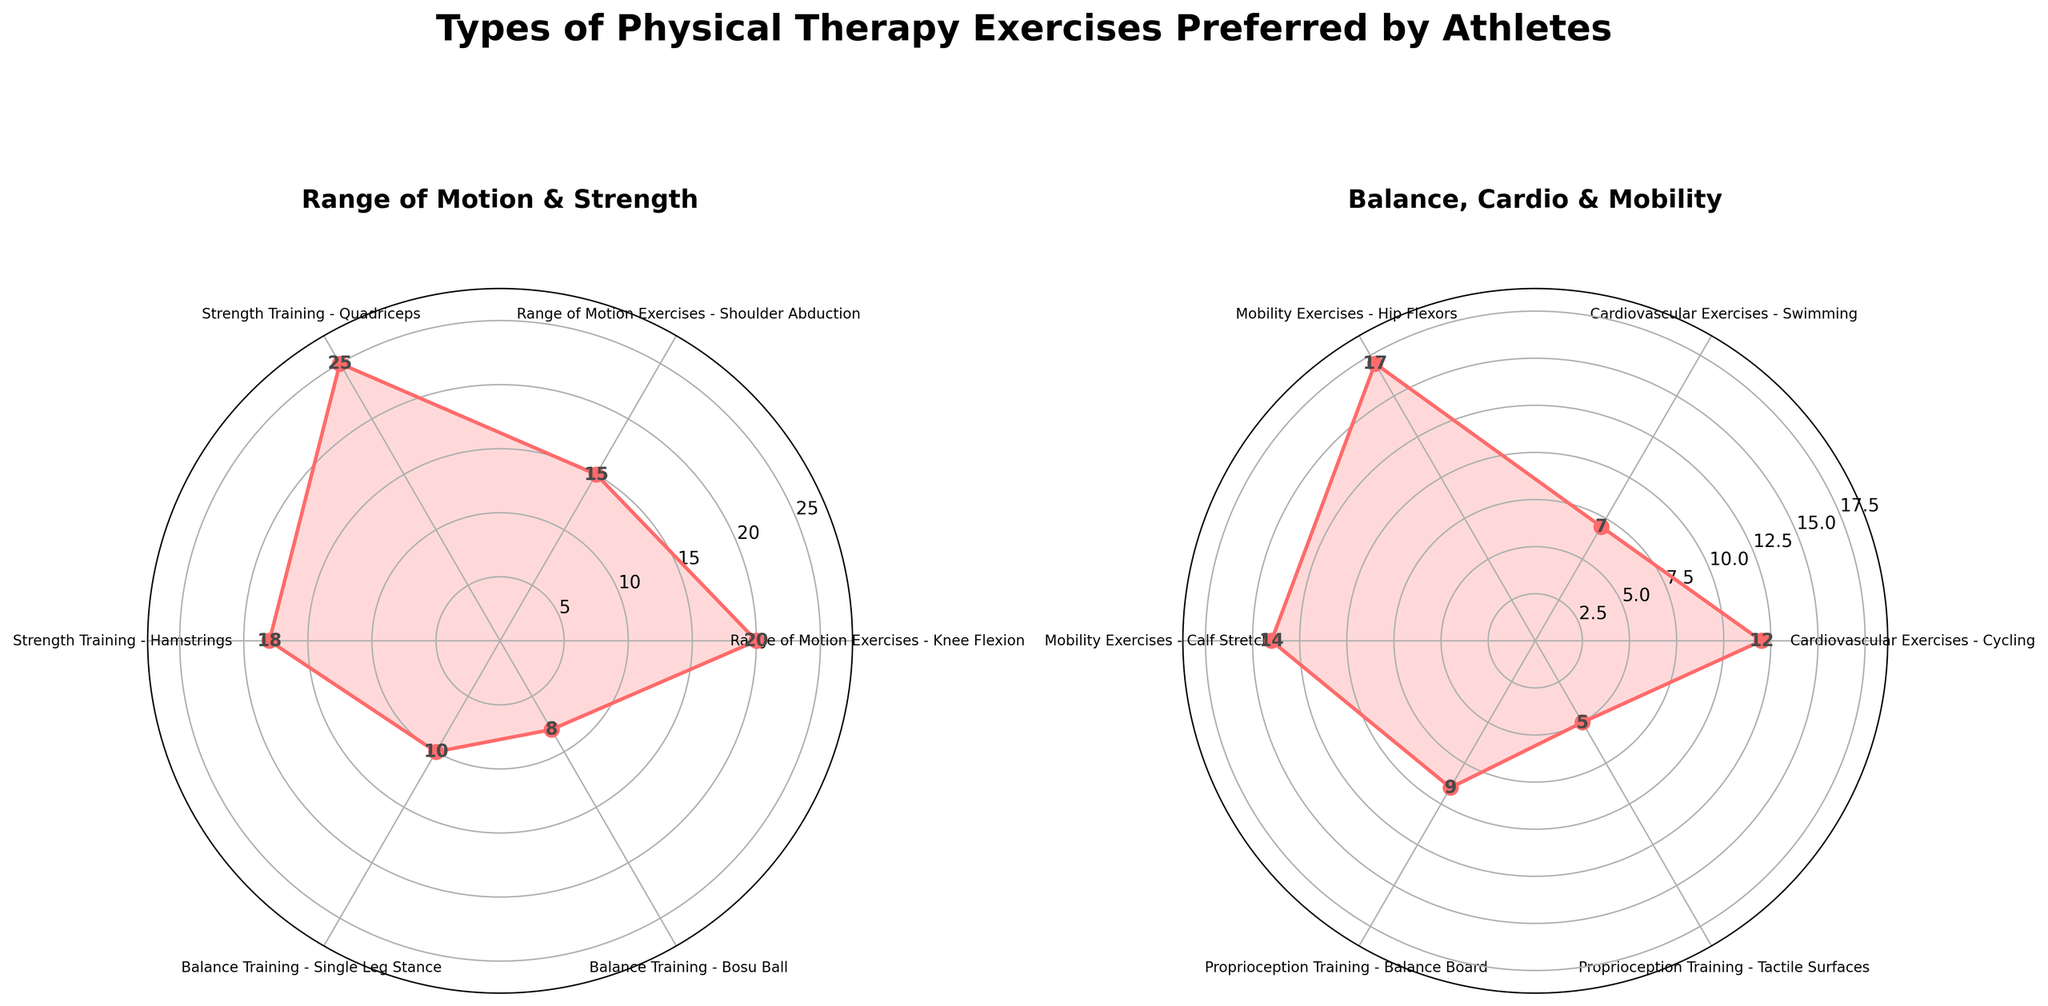What are the two main categories displayed in the figure? The title of each subplot mentions the categories. The left subplot shows "Range of Motion & Strength," and the right subplot shows "Balance, Cardio & Mobility."
Answer: Range of Motion & Strength, Balance, Cardio & Mobility Which exercise type has the highest frequency in the "Range of Motion & Strength" category? In the left subplot ("Range of Motion & Strength"), the category with the highest value is "Strength Training - Quadriceps" with a frequency of 25.
Answer: Strength Training - Quadriceps What is the frequency difference between "Range of Motion Exercises - Knee Flexion" and "Cardiovascular Exercises - Swimming"? The frequency of "Range of Motion Exercises - Knee Flexion" is 20, and the frequency of "Cardiovascular Exercises - Swimming" is 7. The difference is 20 - 7 = 13.
Answer: 13 Which exercise type has the second-highest frequency in the "Balance, Cardio & Mobility" category? In the right subplot ("Balance, Cardio & Mobility"), the second-highest frequency is for "Mobility Exercises - Hip Flexors," which is 17.
Answer: Mobility Exercises - Hip Flexors What is the total frequency of all exercise types in the "Range of Motion & Strength" category? Sum the frequencies in the left subplot: 20 + 15 + 25 + 18 = 78.
Answer: 78 Which category has more exercise types, "Range of Motion & Strength" or "Balance, Cardio & Mobility"? "Range of Motion & Strength" has 4 types, while "Balance, Cardio & Mobility" has 8 types.
Answer: Balance, Cardio & Mobility What is the combined frequency of both "Proprioception Training" exercises? Add the frequencies: "Balance Board" (9) + "Tactile Surfaces" (5) = 14.
Answer: 14 Are there any exercise types with a frequency of 10 or less? If so, name them. The exercise types with a frequency of 10 or less are "Balance Training - Single Leg Stance" (10), "Balance Training - Bosu Ball" (8), "Cardiovascular Exercises - Swimming" (7), and "Proprioception Training - Tactile Surfaces" (5).
Answer: Balance Training - Single Leg Stance, Balance Training - Bosu Ball, Cardiovascular Exercises - Swimming, Proprioception Training - Tactile Surfaces Which exercise type has the lowest frequency in the "Balance, Cardio & Mobility" category? In the right subplot, the exercise with the lowest frequency is "Proprioception Training - Tactile Surfaces" with a frequency of 5.
Answer: Proprioception Training - Tactile Surfaces 